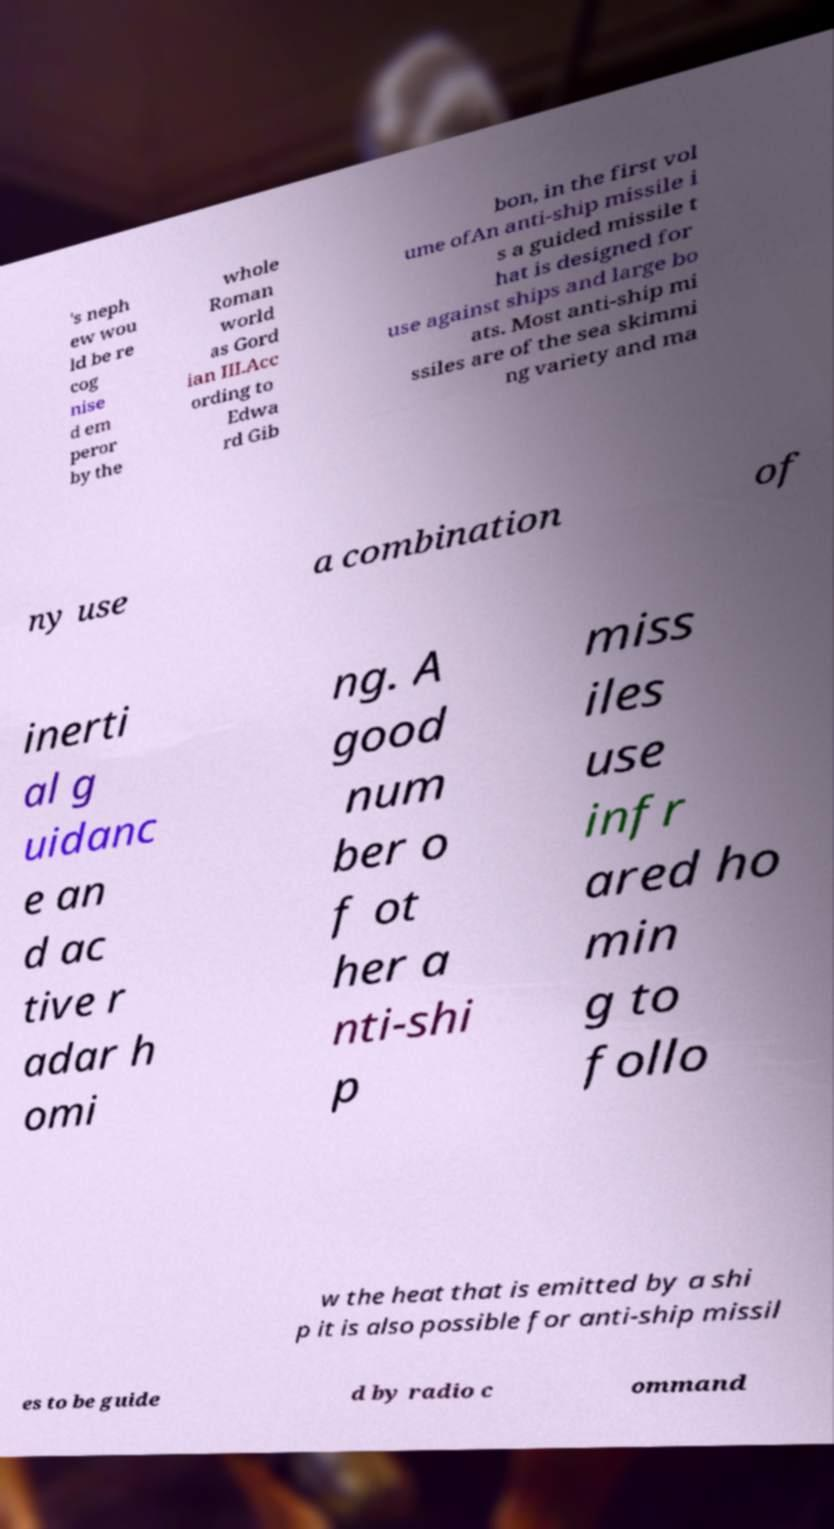There's text embedded in this image that I need extracted. Can you transcribe it verbatim? 's neph ew wou ld be re cog nise d em peror by the whole Roman world as Gord ian III.Acc ording to Edwa rd Gib bon, in the first vol ume ofAn anti-ship missile i s a guided missile t hat is designed for use against ships and large bo ats. Most anti-ship mi ssiles are of the sea skimmi ng variety and ma ny use a combination of inerti al g uidanc e an d ac tive r adar h omi ng. A good num ber o f ot her a nti-shi p miss iles use infr ared ho min g to follo w the heat that is emitted by a shi p it is also possible for anti-ship missil es to be guide d by radio c ommand 